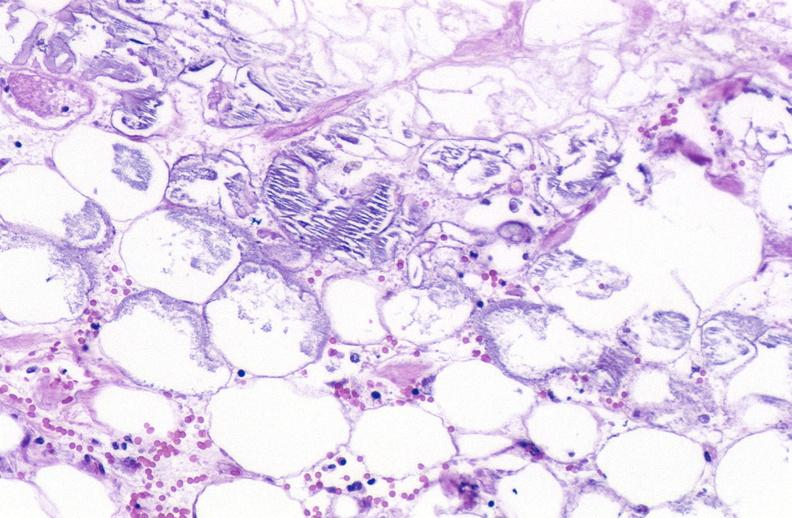what does this image show?
Answer the question using a single word or phrase. Pancreatic fat necrosis 